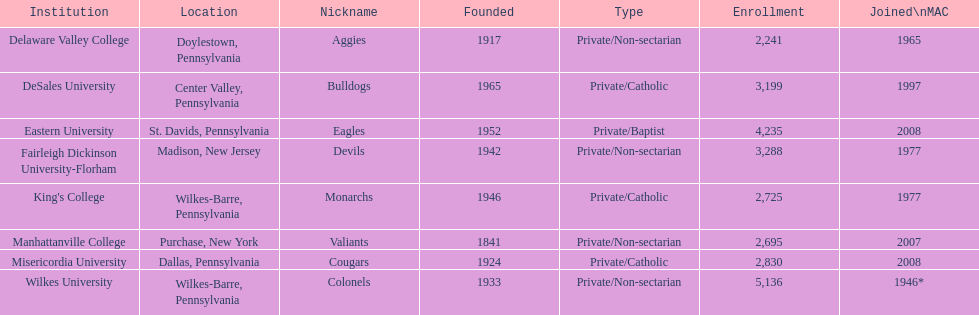How many individuals are registered in private/catholic schools? 8,754. 